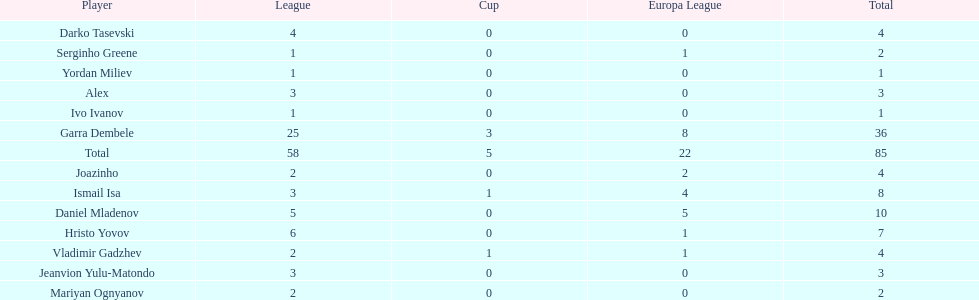Which players only scored one goal? Serginho Greene, Yordan Miliev, Ivo Ivanov. 